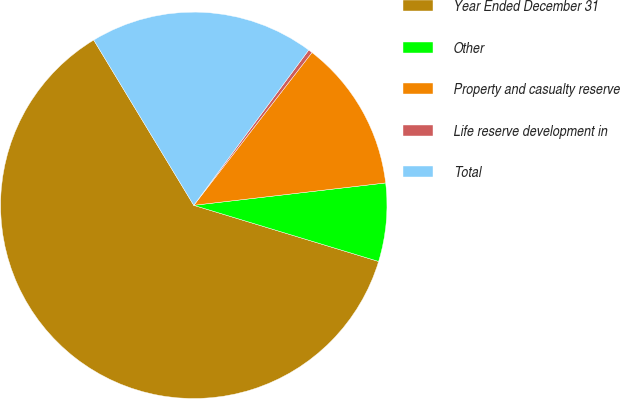Convert chart to OTSL. <chart><loc_0><loc_0><loc_500><loc_500><pie_chart><fcel>Year Ended December 31<fcel>Other<fcel>Property and casualty reserve<fcel>Life reserve development in<fcel>Total<nl><fcel>61.64%<fcel>6.54%<fcel>12.67%<fcel>0.34%<fcel>18.8%<nl></chart> 